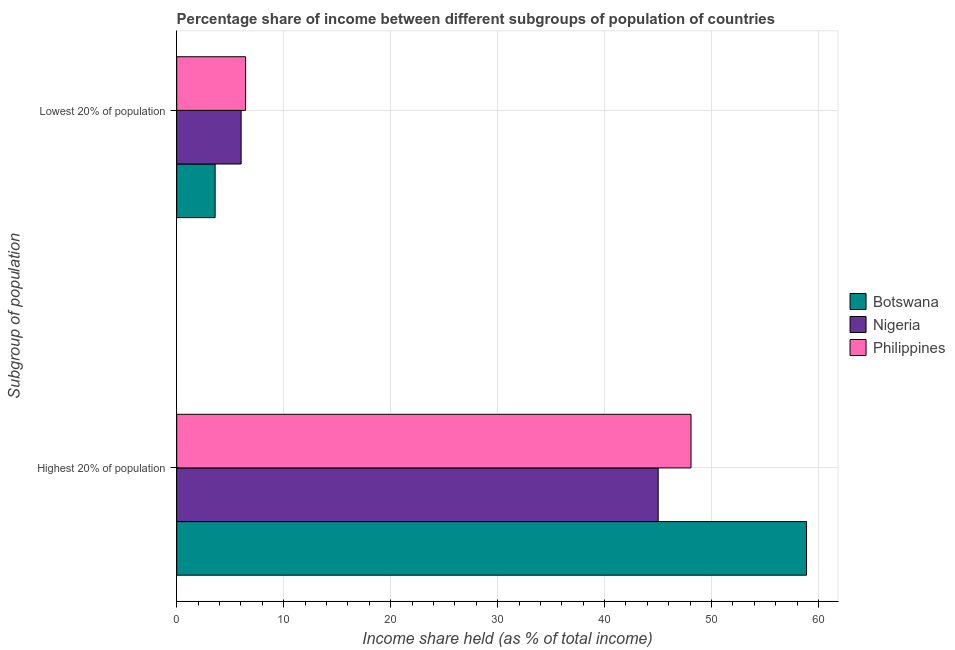How many different coloured bars are there?
Keep it short and to the point. 3. How many groups of bars are there?
Make the answer very short. 2. Are the number of bars on each tick of the Y-axis equal?
Ensure brevity in your answer.  Yes. How many bars are there on the 2nd tick from the bottom?
Make the answer very short. 3. What is the label of the 1st group of bars from the top?
Your response must be concise. Lowest 20% of population. What is the income share held by lowest 20% of the population in Botswana?
Give a very brief answer. 3.59. Across all countries, what is the maximum income share held by highest 20% of the population?
Keep it short and to the point. 58.88. Across all countries, what is the minimum income share held by highest 20% of the population?
Your response must be concise. 45.01. In which country was the income share held by highest 20% of the population maximum?
Ensure brevity in your answer.  Botswana. In which country was the income share held by highest 20% of the population minimum?
Offer a very short reply. Nigeria. What is the total income share held by highest 20% of the population in the graph?
Give a very brief answer. 151.97. What is the difference between the income share held by lowest 20% of the population in Philippines and that in Botswana?
Provide a short and direct response. 2.85. What is the difference between the income share held by highest 20% of the population in Botswana and the income share held by lowest 20% of the population in Nigeria?
Provide a succinct answer. 52.86. What is the average income share held by lowest 20% of the population per country?
Provide a succinct answer. 5.35. What is the difference between the income share held by lowest 20% of the population and income share held by highest 20% of the population in Nigeria?
Your answer should be very brief. -38.99. In how many countries, is the income share held by lowest 20% of the population greater than 16 %?
Your answer should be very brief. 0. What is the ratio of the income share held by highest 20% of the population in Botswana to that in Philippines?
Offer a terse response. 1.22. What does the 2nd bar from the top in Highest 20% of population represents?
Provide a short and direct response. Nigeria. What does the 1st bar from the bottom in Highest 20% of population represents?
Give a very brief answer. Botswana. What is the difference between two consecutive major ticks on the X-axis?
Give a very brief answer. 10. Does the graph contain any zero values?
Your answer should be very brief. No. Where does the legend appear in the graph?
Your response must be concise. Center right. How many legend labels are there?
Keep it short and to the point. 3. How are the legend labels stacked?
Ensure brevity in your answer.  Vertical. What is the title of the graph?
Provide a succinct answer. Percentage share of income between different subgroups of population of countries. What is the label or title of the X-axis?
Give a very brief answer. Income share held (as % of total income). What is the label or title of the Y-axis?
Your response must be concise. Subgroup of population. What is the Income share held (as % of total income) in Botswana in Highest 20% of population?
Ensure brevity in your answer.  58.88. What is the Income share held (as % of total income) of Nigeria in Highest 20% of population?
Make the answer very short. 45.01. What is the Income share held (as % of total income) of Philippines in Highest 20% of population?
Give a very brief answer. 48.08. What is the Income share held (as % of total income) of Botswana in Lowest 20% of population?
Make the answer very short. 3.59. What is the Income share held (as % of total income) in Nigeria in Lowest 20% of population?
Ensure brevity in your answer.  6.02. What is the Income share held (as % of total income) of Philippines in Lowest 20% of population?
Your answer should be very brief. 6.44. Across all Subgroup of population, what is the maximum Income share held (as % of total income) in Botswana?
Your answer should be compact. 58.88. Across all Subgroup of population, what is the maximum Income share held (as % of total income) in Nigeria?
Your answer should be compact. 45.01. Across all Subgroup of population, what is the maximum Income share held (as % of total income) of Philippines?
Your response must be concise. 48.08. Across all Subgroup of population, what is the minimum Income share held (as % of total income) in Botswana?
Offer a terse response. 3.59. Across all Subgroup of population, what is the minimum Income share held (as % of total income) of Nigeria?
Make the answer very short. 6.02. Across all Subgroup of population, what is the minimum Income share held (as % of total income) in Philippines?
Your response must be concise. 6.44. What is the total Income share held (as % of total income) in Botswana in the graph?
Ensure brevity in your answer.  62.47. What is the total Income share held (as % of total income) of Nigeria in the graph?
Ensure brevity in your answer.  51.03. What is the total Income share held (as % of total income) of Philippines in the graph?
Keep it short and to the point. 54.52. What is the difference between the Income share held (as % of total income) in Botswana in Highest 20% of population and that in Lowest 20% of population?
Make the answer very short. 55.29. What is the difference between the Income share held (as % of total income) of Nigeria in Highest 20% of population and that in Lowest 20% of population?
Your answer should be compact. 38.99. What is the difference between the Income share held (as % of total income) of Philippines in Highest 20% of population and that in Lowest 20% of population?
Make the answer very short. 41.64. What is the difference between the Income share held (as % of total income) of Botswana in Highest 20% of population and the Income share held (as % of total income) of Nigeria in Lowest 20% of population?
Provide a succinct answer. 52.86. What is the difference between the Income share held (as % of total income) in Botswana in Highest 20% of population and the Income share held (as % of total income) in Philippines in Lowest 20% of population?
Keep it short and to the point. 52.44. What is the difference between the Income share held (as % of total income) of Nigeria in Highest 20% of population and the Income share held (as % of total income) of Philippines in Lowest 20% of population?
Offer a very short reply. 38.57. What is the average Income share held (as % of total income) of Botswana per Subgroup of population?
Offer a very short reply. 31.23. What is the average Income share held (as % of total income) in Nigeria per Subgroup of population?
Your answer should be compact. 25.52. What is the average Income share held (as % of total income) in Philippines per Subgroup of population?
Make the answer very short. 27.26. What is the difference between the Income share held (as % of total income) of Botswana and Income share held (as % of total income) of Nigeria in Highest 20% of population?
Ensure brevity in your answer.  13.87. What is the difference between the Income share held (as % of total income) of Botswana and Income share held (as % of total income) of Philippines in Highest 20% of population?
Your answer should be compact. 10.8. What is the difference between the Income share held (as % of total income) of Nigeria and Income share held (as % of total income) of Philippines in Highest 20% of population?
Make the answer very short. -3.07. What is the difference between the Income share held (as % of total income) of Botswana and Income share held (as % of total income) of Nigeria in Lowest 20% of population?
Make the answer very short. -2.43. What is the difference between the Income share held (as % of total income) in Botswana and Income share held (as % of total income) in Philippines in Lowest 20% of population?
Your answer should be compact. -2.85. What is the difference between the Income share held (as % of total income) of Nigeria and Income share held (as % of total income) of Philippines in Lowest 20% of population?
Your answer should be compact. -0.42. What is the ratio of the Income share held (as % of total income) in Botswana in Highest 20% of population to that in Lowest 20% of population?
Make the answer very short. 16.4. What is the ratio of the Income share held (as % of total income) in Nigeria in Highest 20% of population to that in Lowest 20% of population?
Make the answer very short. 7.48. What is the ratio of the Income share held (as % of total income) of Philippines in Highest 20% of population to that in Lowest 20% of population?
Give a very brief answer. 7.47. What is the difference between the highest and the second highest Income share held (as % of total income) in Botswana?
Make the answer very short. 55.29. What is the difference between the highest and the second highest Income share held (as % of total income) in Nigeria?
Provide a succinct answer. 38.99. What is the difference between the highest and the second highest Income share held (as % of total income) in Philippines?
Offer a terse response. 41.64. What is the difference between the highest and the lowest Income share held (as % of total income) in Botswana?
Ensure brevity in your answer.  55.29. What is the difference between the highest and the lowest Income share held (as % of total income) in Nigeria?
Give a very brief answer. 38.99. What is the difference between the highest and the lowest Income share held (as % of total income) in Philippines?
Give a very brief answer. 41.64. 